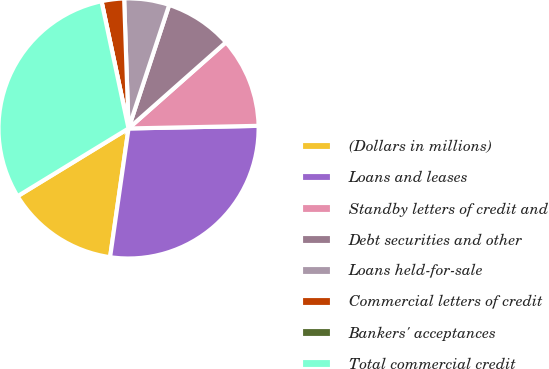Convert chart. <chart><loc_0><loc_0><loc_500><loc_500><pie_chart><fcel>(Dollars in millions)<fcel>Loans and leases<fcel>Standby letters of credit and<fcel>Debt securities and other<fcel>Loans held-for-sale<fcel>Commercial letters of credit<fcel>Bankers' acceptances<fcel>Total commercial credit<nl><fcel>14.01%<fcel>27.59%<fcel>11.21%<fcel>8.41%<fcel>5.6%<fcel>2.8%<fcel>0.0%<fcel>30.39%<nl></chart> 